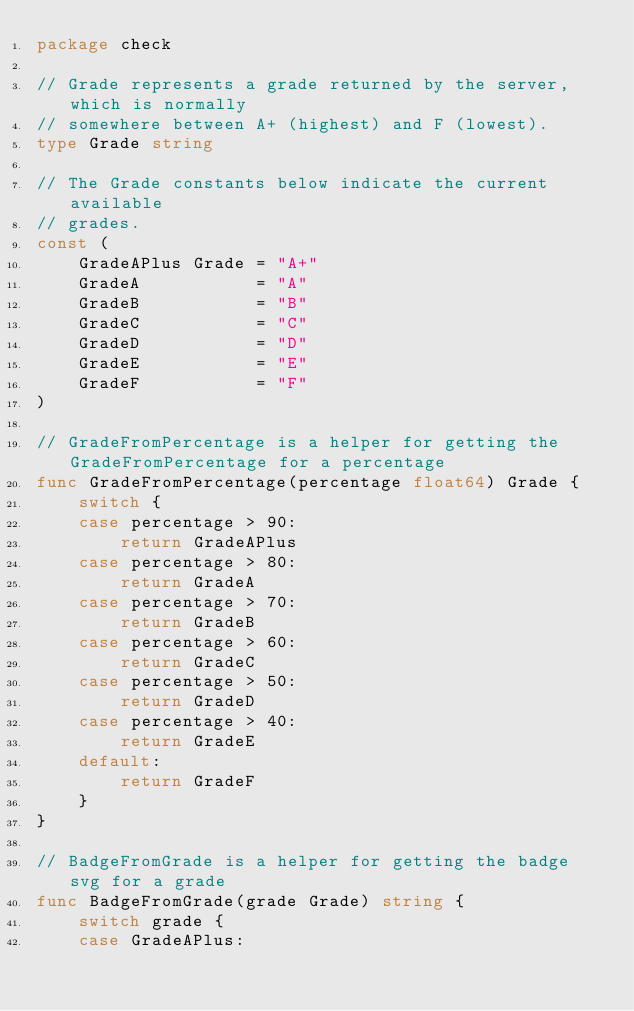<code> <loc_0><loc_0><loc_500><loc_500><_Go_>package check

// Grade represents a grade returned by the server, which is normally
// somewhere between A+ (highest) and F (lowest).
type Grade string

// The Grade constants below indicate the current available
// grades.
const (
	GradeAPlus Grade = "A+"
	GradeA           = "A"
	GradeB           = "B"
	GradeC           = "C"
	GradeD           = "D"
	GradeE           = "E"
	GradeF           = "F"
)

// GradeFromPercentage is a helper for getting the GradeFromPercentage for a percentage
func GradeFromPercentage(percentage float64) Grade {
	switch {
	case percentage > 90:
		return GradeAPlus
	case percentage > 80:
		return GradeA
	case percentage > 70:
		return GradeB
	case percentage > 60:
		return GradeC
	case percentage > 50:
		return GradeD
	case percentage > 40:
		return GradeE
	default:
		return GradeF
	}
}

// BadgeFromGrade is a helper for getting the badge svg for a grade
func BadgeFromGrade(grade Grade) string {
	switch grade {
	case GradeAPlus:</code> 